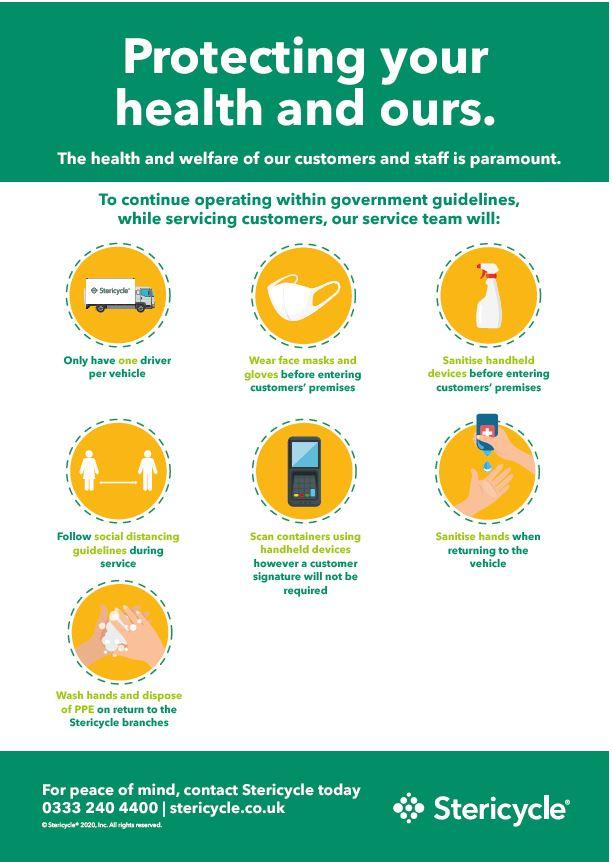Highlight a few significant elements in this photo. The number of masks depicted in this infographic image is 1.. 